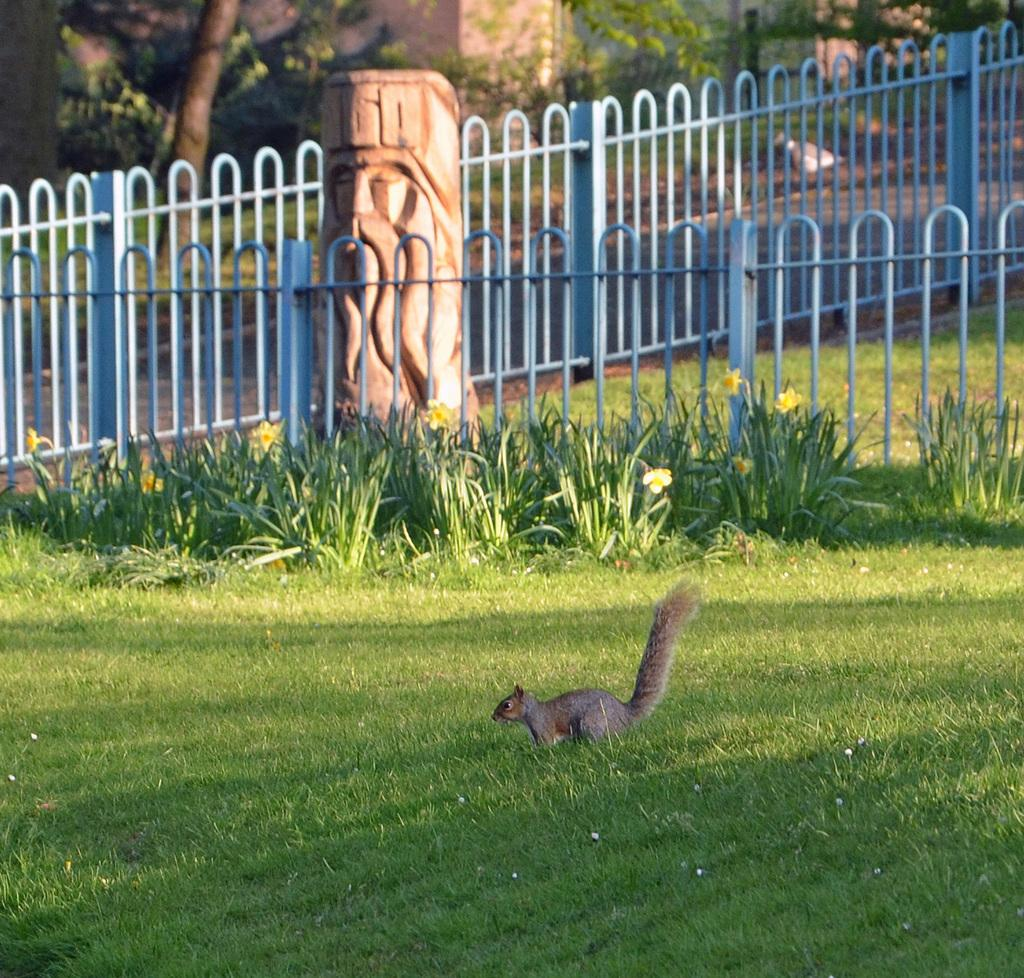What type of animal can be seen in the image? There is a squirrel in the image. What type of vegetation is present in the image? There is grass in the image. What type of structure can be seen in the image? There is an iron railing in the image. What can be seen in the background of the image? There are buildings and trees visible in the background of the image. Where might this image have been taken? The image might have been taken in a garden. What type of ornament is hanging from the squirrel's tail in the image? There is no ornament hanging from the squirrel's tail in the image; the squirrel is not adorned with any decorations. 